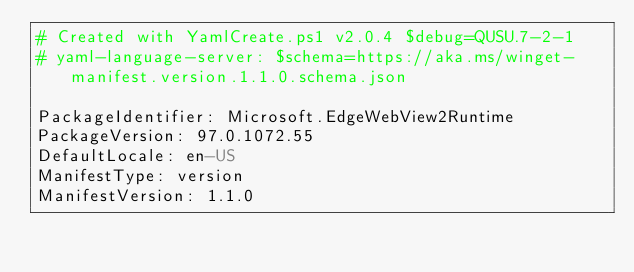Convert code to text. <code><loc_0><loc_0><loc_500><loc_500><_YAML_># Created with YamlCreate.ps1 v2.0.4 $debug=QUSU.7-2-1
# yaml-language-server: $schema=https://aka.ms/winget-manifest.version.1.1.0.schema.json

PackageIdentifier: Microsoft.EdgeWebView2Runtime
PackageVersion: 97.0.1072.55
DefaultLocale: en-US
ManifestType: version
ManifestVersion: 1.1.0
</code> 